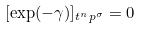<formula> <loc_0><loc_0><loc_500><loc_500>[ \exp ( - \gamma ) ] _ { t ^ { n } p ^ { \sigma } } = 0</formula> 